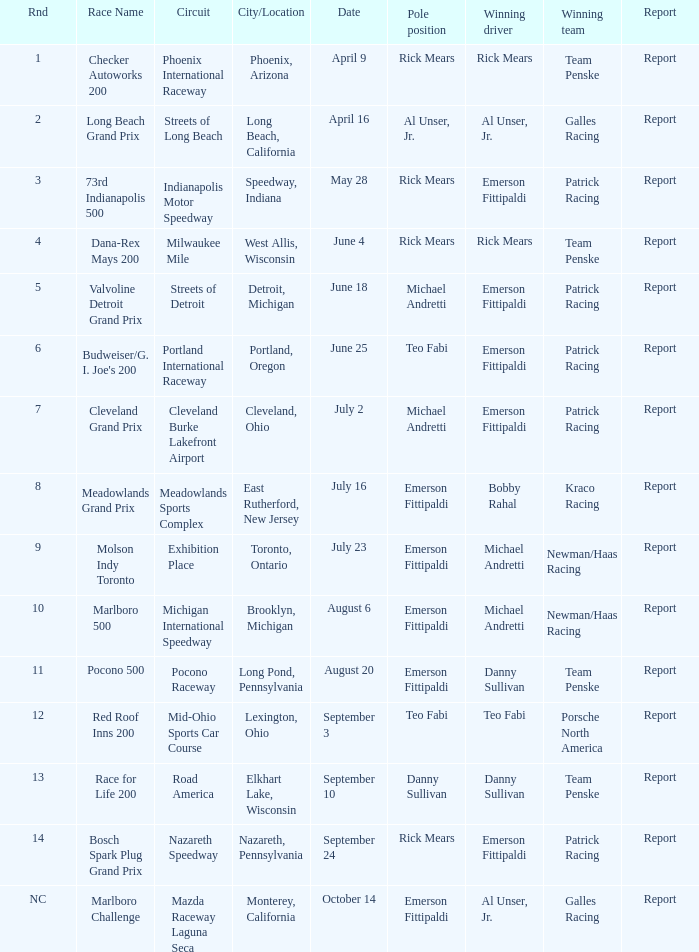What routes were there for the phoenix international raceway? 1.0. 